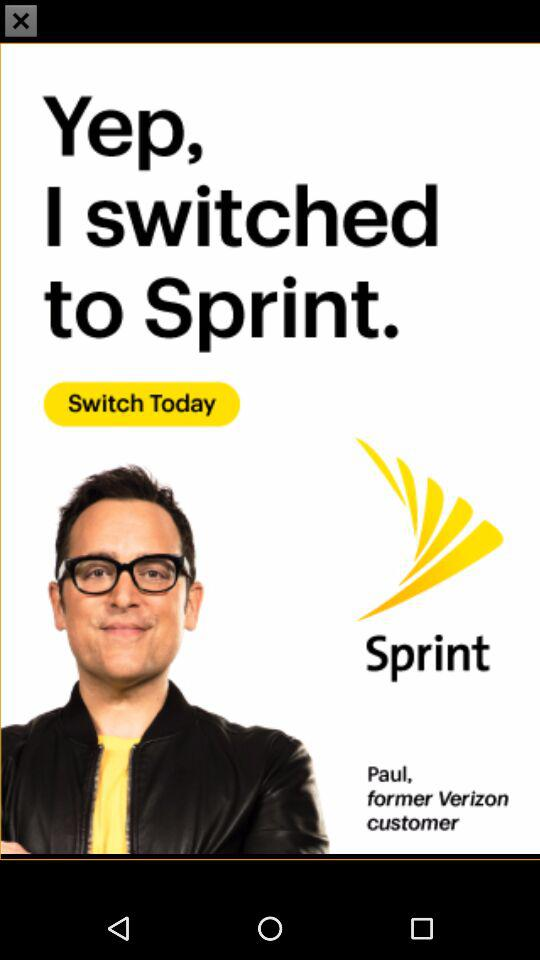What is the name of the application? The name of the application is "Sprint". 